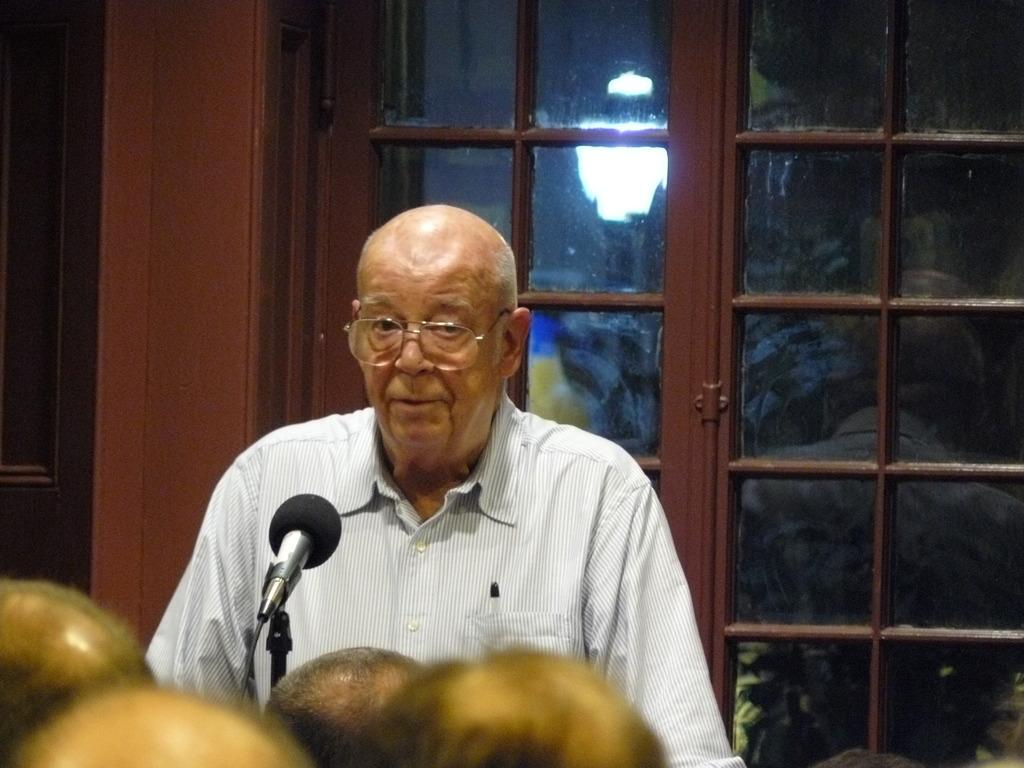Who is the main subject in the image? There is a man in the image. What is in front of the man? There is a mic in front of the man. Who is present in front of the man? There are people in front of the man. What can be seen behind the man? There are windows behind the man. What type of glue is being used by the man in the image? There is no glue present in the image; the man is standing in front of a mic. 